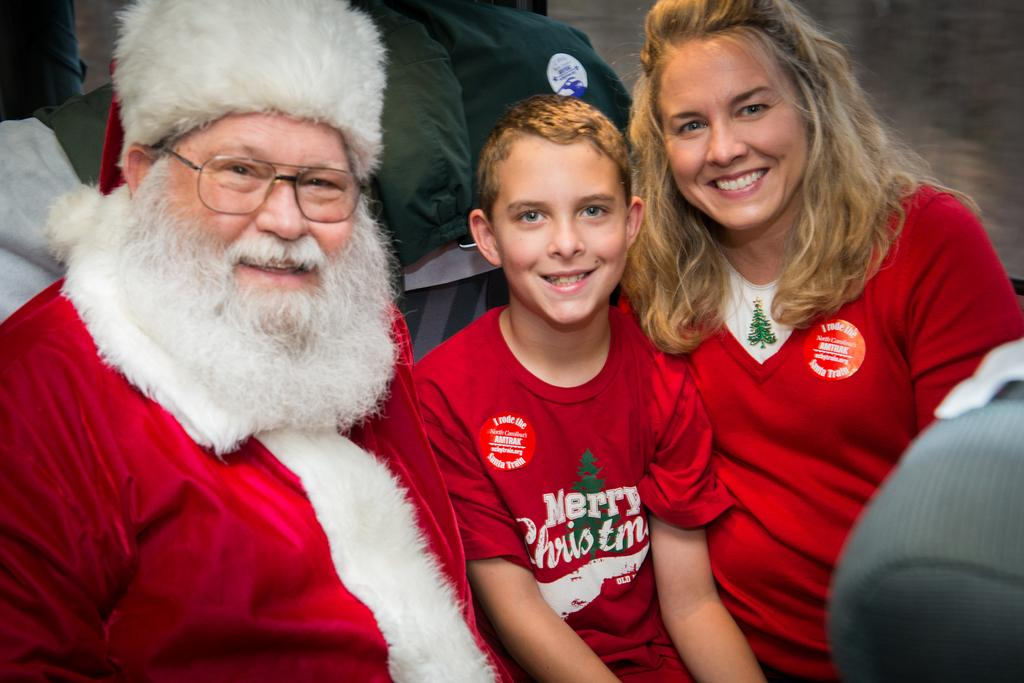What is the person in the image wearing on their face? The person in the image is wearing spectacles. What else is the person wearing in the image? The person is also wearing a cap. Who is beside the person in the image? There is a boy beside the person in the image. What can be seen on the right side of the image? There is a woman on the right side of the image. Where are the people in the image sitting? The people are sitting on a bench in the image. What type of cactus is growing on the person's head in the image? There is no cactus present on the person's head in the image. 